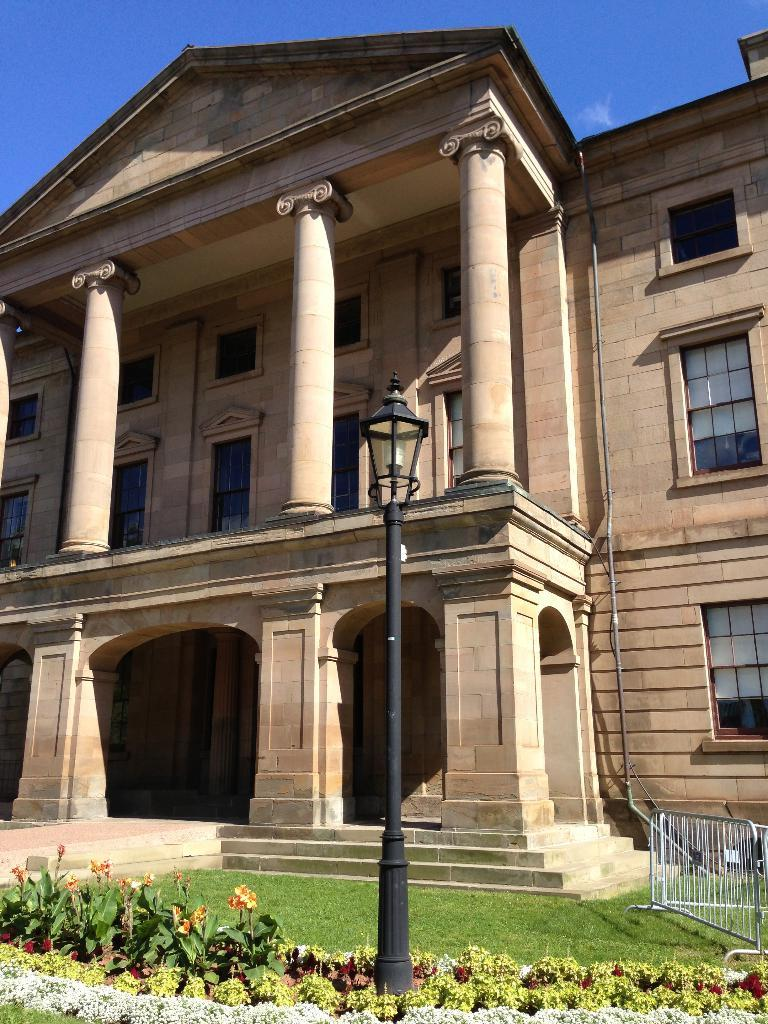What type of vegetation is present in the image? There are flowering plants and grass in the image. What type of structure can be seen in the image? There is a fence, a pole, and a building in the image. What part of the building is visible in the image? There are windows in the image, which suggests that the building's exterior is visible. What is visible in the background of the image? The sky is visible in the image. Can you determine the time of day the image was taken? The image was likely taken during the day, as the sky is visible and there is no indication of darkness. How many people are trying to join the frame in the image? There are no people visible in the image, so it is not possible to determine if anyone is trying to join the frame. 